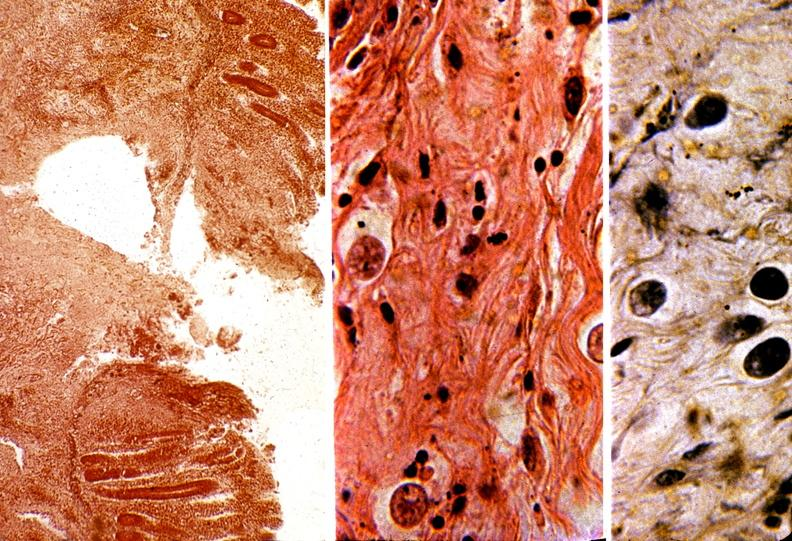s gastrointestinal present?
Answer the question using a single word or phrase. Yes 